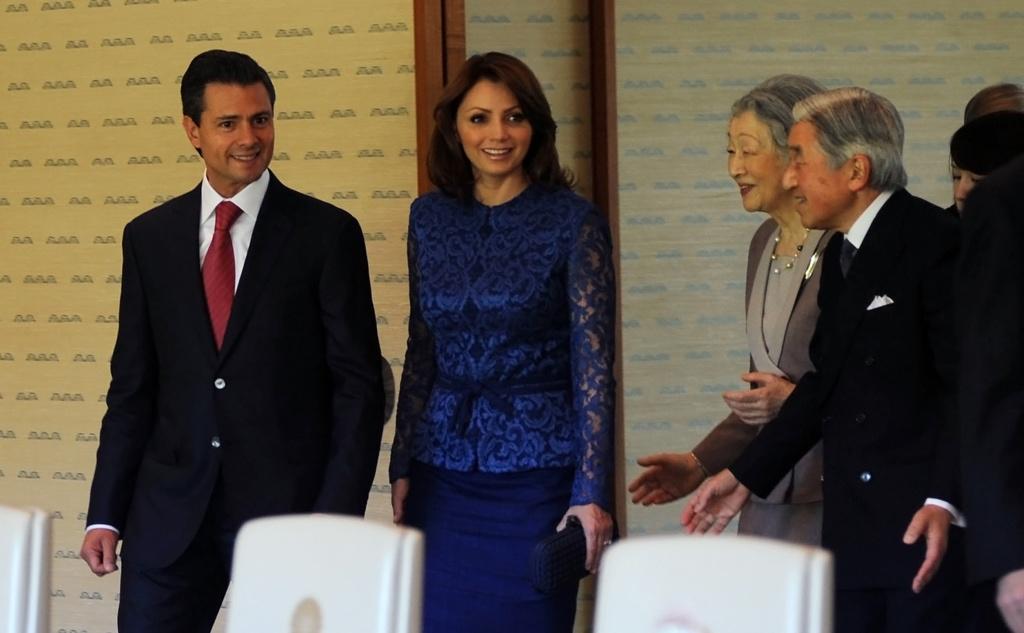Please provide a concise description of this image. In this picture I can see two persons standing and smiling, there are chairs, and there are group of people standing, and in the background there is a wall. 